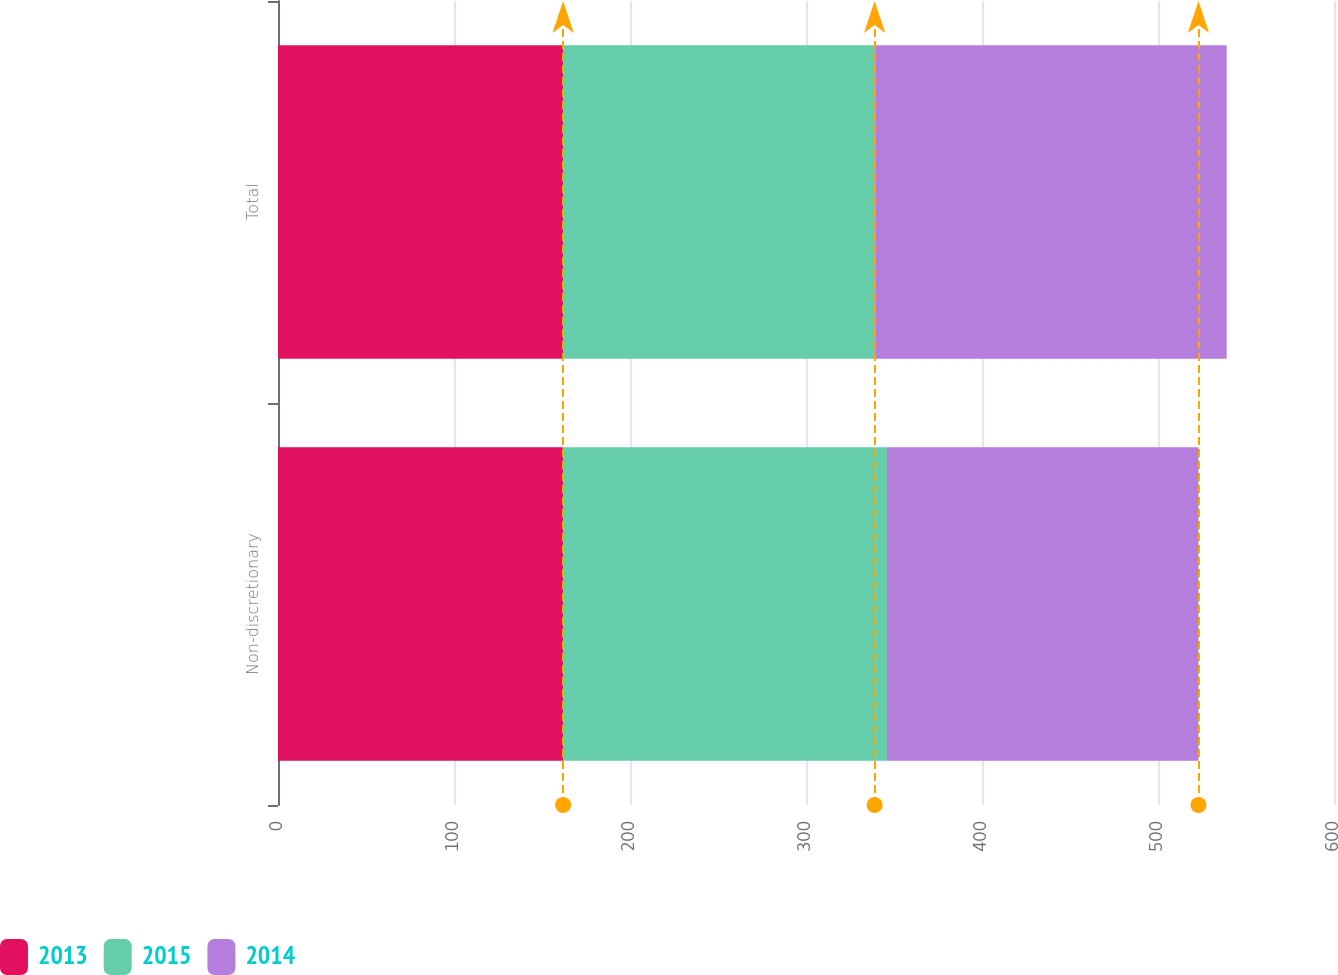Convert chart to OTSL. <chart><loc_0><loc_0><loc_500><loc_500><stacked_bar_chart><ecel><fcel>Non-discretionary<fcel>Total<nl><fcel>2013<fcel>162<fcel>162<nl><fcel>2015<fcel>184<fcel>177<nl><fcel>2014<fcel>177<fcel>200<nl></chart> 